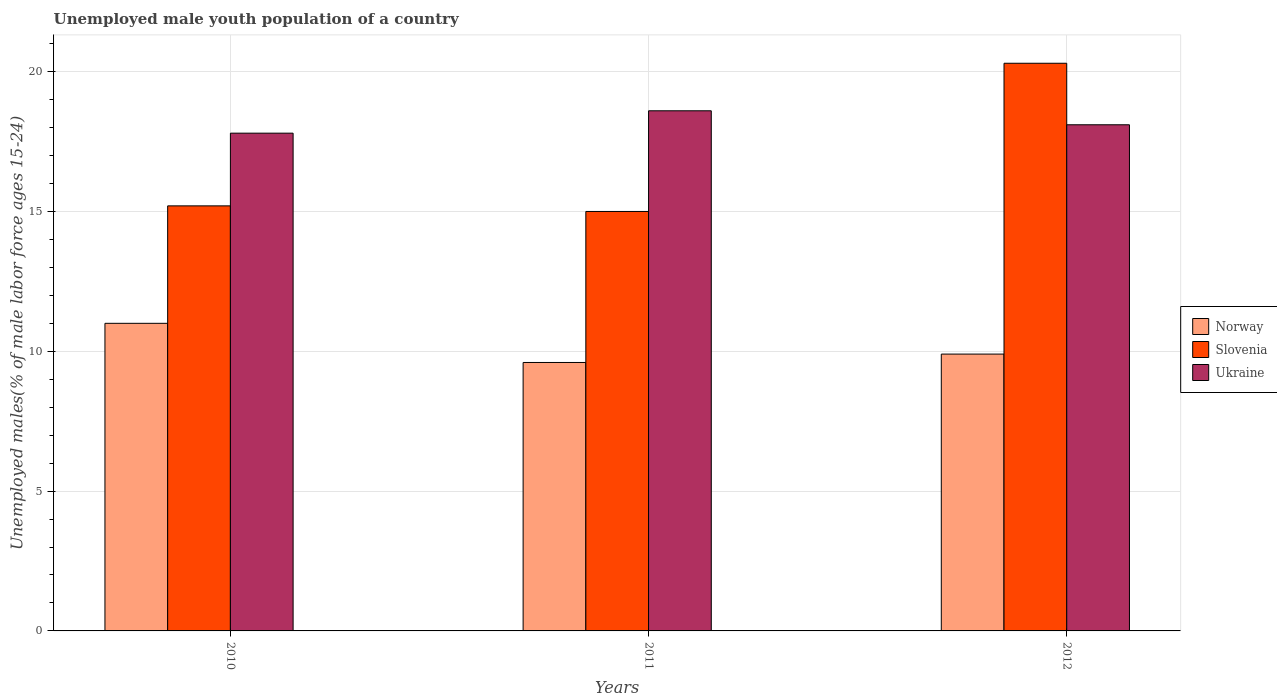Are the number of bars per tick equal to the number of legend labels?
Make the answer very short. Yes. Are the number of bars on each tick of the X-axis equal?
Ensure brevity in your answer.  Yes. How many bars are there on the 2nd tick from the left?
Give a very brief answer. 3. How many bars are there on the 3rd tick from the right?
Give a very brief answer. 3. What is the label of the 2nd group of bars from the left?
Make the answer very short. 2011. What is the percentage of unemployed male youth population in Norway in 2012?
Keep it short and to the point. 9.9. Across all years, what is the maximum percentage of unemployed male youth population in Slovenia?
Keep it short and to the point. 20.3. Across all years, what is the minimum percentage of unemployed male youth population in Norway?
Provide a short and direct response. 9.6. In which year was the percentage of unemployed male youth population in Norway maximum?
Provide a succinct answer. 2010. What is the total percentage of unemployed male youth population in Norway in the graph?
Ensure brevity in your answer.  30.5. What is the difference between the percentage of unemployed male youth population in Slovenia in 2011 and that in 2012?
Give a very brief answer. -5.3. What is the difference between the percentage of unemployed male youth population in Slovenia in 2011 and the percentage of unemployed male youth population in Norway in 2012?
Provide a short and direct response. 5.1. What is the average percentage of unemployed male youth population in Ukraine per year?
Ensure brevity in your answer.  18.17. In the year 2010, what is the difference between the percentage of unemployed male youth population in Norway and percentage of unemployed male youth population in Slovenia?
Offer a very short reply. -4.2. In how many years, is the percentage of unemployed male youth population in Ukraine greater than 12 %?
Ensure brevity in your answer.  3. What is the ratio of the percentage of unemployed male youth population in Norway in 2010 to that in 2011?
Give a very brief answer. 1.15. Is the difference between the percentage of unemployed male youth population in Norway in 2010 and 2012 greater than the difference between the percentage of unemployed male youth population in Slovenia in 2010 and 2012?
Provide a short and direct response. Yes. What is the difference between the highest and the second highest percentage of unemployed male youth population in Slovenia?
Provide a short and direct response. 5.1. What is the difference between the highest and the lowest percentage of unemployed male youth population in Slovenia?
Give a very brief answer. 5.3. In how many years, is the percentage of unemployed male youth population in Ukraine greater than the average percentage of unemployed male youth population in Ukraine taken over all years?
Ensure brevity in your answer.  1. Is the sum of the percentage of unemployed male youth population in Norway in 2010 and 2012 greater than the maximum percentage of unemployed male youth population in Ukraine across all years?
Your response must be concise. Yes. What does the 2nd bar from the left in 2010 represents?
Your answer should be very brief. Slovenia. What does the 2nd bar from the right in 2010 represents?
Offer a terse response. Slovenia. Is it the case that in every year, the sum of the percentage of unemployed male youth population in Norway and percentage of unemployed male youth population in Ukraine is greater than the percentage of unemployed male youth population in Slovenia?
Your answer should be compact. Yes. Are all the bars in the graph horizontal?
Make the answer very short. No. Are the values on the major ticks of Y-axis written in scientific E-notation?
Your response must be concise. No. Does the graph contain grids?
Provide a succinct answer. Yes. What is the title of the graph?
Provide a succinct answer. Unemployed male youth population of a country. What is the label or title of the X-axis?
Offer a terse response. Years. What is the label or title of the Y-axis?
Offer a terse response. Unemployed males(% of male labor force ages 15-24). What is the Unemployed males(% of male labor force ages 15-24) in Slovenia in 2010?
Your response must be concise. 15.2. What is the Unemployed males(% of male labor force ages 15-24) of Ukraine in 2010?
Your response must be concise. 17.8. What is the Unemployed males(% of male labor force ages 15-24) in Norway in 2011?
Provide a short and direct response. 9.6. What is the Unemployed males(% of male labor force ages 15-24) of Slovenia in 2011?
Make the answer very short. 15. What is the Unemployed males(% of male labor force ages 15-24) in Ukraine in 2011?
Provide a succinct answer. 18.6. What is the Unemployed males(% of male labor force ages 15-24) of Norway in 2012?
Your answer should be very brief. 9.9. What is the Unemployed males(% of male labor force ages 15-24) of Slovenia in 2012?
Make the answer very short. 20.3. What is the Unemployed males(% of male labor force ages 15-24) of Ukraine in 2012?
Give a very brief answer. 18.1. Across all years, what is the maximum Unemployed males(% of male labor force ages 15-24) in Slovenia?
Ensure brevity in your answer.  20.3. Across all years, what is the maximum Unemployed males(% of male labor force ages 15-24) of Ukraine?
Ensure brevity in your answer.  18.6. Across all years, what is the minimum Unemployed males(% of male labor force ages 15-24) in Norway?
Give a very brief answer. 9.6. Across all years, what is the minimum Unemployed males(% of male labor force ages 15-24) of Ukraine?
Your response must be concise. 17.8. What is the total Unemployed males(% of male labor force ages 15-24) in Norway in the graph?
Your answer should be compact. 30.5. What is the total Unemployed males(% of male labor force ages 15-24) in Slovenia in the graph?
Your response must be concise. 50.5. What is the total Unemployed males(% of male labor force ages 15-24) in Ukraine in the graph?
Give a very brief answer. 54.5. What is the difference between the Unemployed males(% of male labor force ages 15-24) in Ukraine in 2010 and that in 2011?
Your answer should be very brief. -0.8. What is the difference between the Unemployed males(% of male labor force ages 15-24) of Norway in 2010 and that in 2012?
Offer a very short reply. 1.1. What is the difference between the Unemployed males(% of male labor force ages 15-24) of Slovenia in 2010 and that in 2012?
Your answer should be very brief. -5.1. What is the difference between the Unemployed males(% of male labor force ages 15-24) in Norway in 2011 and that in 2012?
Give a very brief answer. -0.3. What is the difference between the Unemployed males(% of male labor force ages 15-24) in Slovenia in 2011 and that in 2012?
Provide a succinct answer. -5.3. What is the difference between the Unemployed males(% of male labor force ages 15-24) in Ukraine in 2011 and that in 2012?
Your answer should be very brief. 0.5. What is the difference between the Unemployed males(% of male labor force ages 15-24) of Slovenia in 2010 and the Unemployed males(% of male labor force ages 15-24) of Ukraine in 2011?
Provide a succinct answer. -3.4. What is the difference between the Unemployed males(% of male labor force ages 15-24) in Norway in 2010 and the Unemployed males(% of male labor force ages 15-24) in Slovenia in 2012?
Offer a very short reply. -9.3. What is the difference between the Unemployed males(% of male labor force ages 15-24) in Norway in 2010 and the Unemployed males(% of male labor force ages 15-24) in Ukraine in 2012?
Your answer should be very brief. -7.1. What is the difference between the Unemployed males(% of male labor force ages 15-24) in Slovenia in 2010 and the Unemployed males(% of male labor force ages 15-24) in Ukraine in 2012?
Your response must be concise. -2.9. What is the difference between the Unemployed males(% of male labor force ages 15-24) of Norway in 2011 and the Unemployed males(% of male labor force ages 15-24) of Ukraine in 2012?
Ensure brevity in your answer.  -8.5. What is the difference between the Unemployed males(% of male labor force ages 15-24) of Slovenia in 2011 and the Unemployed males(% of male labor force ages 15-24) of Ukraine in 2012?
Offer a very short reply. -3.1. What is the average Unemployed males(% of male labor force ages 15-24) in Norway per year?
Ensure brevity in your answer.  10.17. What is the average Unemployed males(% of male labor force ages 15-24) in Slovenia per year?
Provide a short and direct response. 16.83. What is the average Unemployed males(% of male labor force ages 15-24) of Ukraine per year?
Give a very brief answer. 18.17. In the year 2010, what is the difference between the Unemployed males(% of male labor force ages 15-24) of Slovenia and Unemployed males(% of male labor force ages 15-24) of Ukraine?
Your response must be concise. -2.6. In the year 2011, what is the difference between the Unemployed males(% of male labor force ages 15-24) in Norway and Unemployed males(% of male labor force ages 15-24) in Ukraine?
Make the answer very short. -9. In the year 2012, what is the difference between the Unemployed males(% of male labor force ages 15-24) in Norway and Unemployed males(% of male labor force ages 15-24) in Ukraine?
Give a very brief answer. -8.2. What is the ratio of the Unemployed males(% of male labor force ages 15-24) in Norway in 2010 to that in 2011?
Offer a very short reply. 1.15. What is the ratio of the Unemployed males(% of male labor force ages 15-24) of Slovenia in 2010 to that in 2011?
Offer a terse response. 1.01. What is the ratio of the Unemployed males(% of male labor force ages 15-24) in Norway in 2010 to that in 2012?
Make the answer very short. 1.11. What is the ratio of the Unemployed males(% of male labor force ages 15-24) in Slovenia in 2010 to that in 2012?
Your response must be concise. 0.75. What is the ratio of the Unemployed males(% of male labor force ages 15-24) in Ukraine in 2010 to that in 2012?
Give a very brief answer. 0.98. What is the ratio of the Unemployed males(% of male labor force ages 15-24) of Norway in 2011 to that in 2012?
Provide a short and direct response. 0.97. What is the ratio of the Unemployed males(% of male labor force ages 15-24) in Slovenia in 2011 to that in 2012?
Your response must be concise. 0.74. What is the ratio of the Unemployed males(% of male labor force ages 15-24) in Ukraine in 2011 to that in 2012?
Make the answer very short. 1.03. What is the difference between the highest and the second highest Unemployed males(% of male labor force ages 15-24) in Norway?
Give a very brief answer. 1.1. What is the difference between the highest and the lowest Unemployed males(% of male labor force ages 15-24) in Norway?
Offer a terse response. 1.4. What is the difference between the highest and the lowest Unemployed males(% of male labor force ages 15-24) of Ukraine?
Your response must be concise. 0.8. 